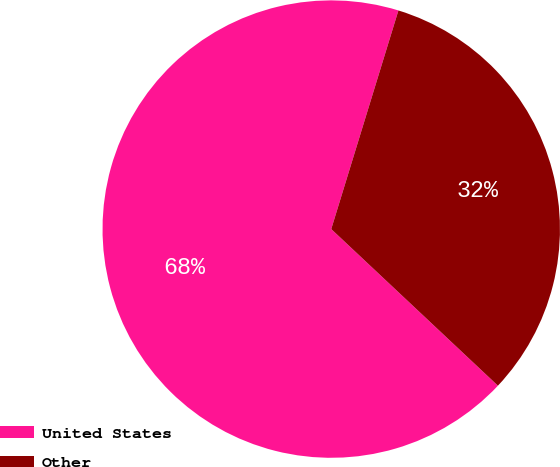Convert chart to OTSL. <chart><loc_0><loc_0><loc_500><loc_500><pie_chart><fcel>United States<fcel>Other<nl><fcel>67.74%<fcel>32.26%<nl></chart> 